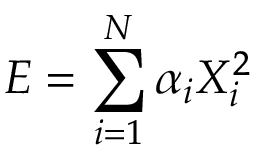<formula> <loc_0><loc_0><loc_500><loc_500>E = \sum _ { i = 1 } ^ { N } \alpha _ { i } X _ { i } ^ { 2 }</formula> 